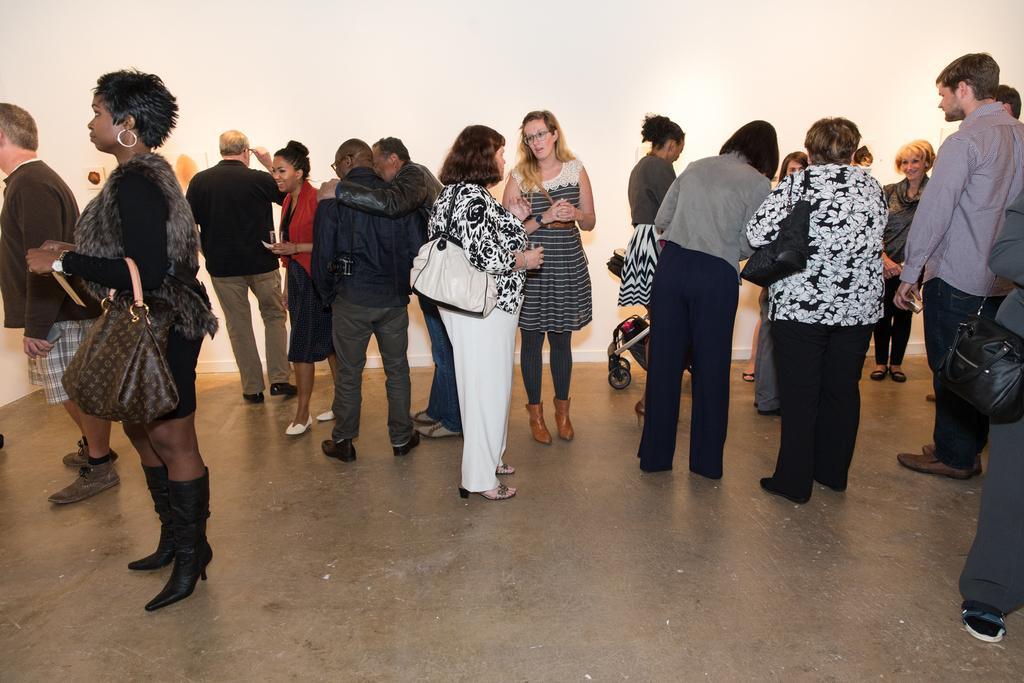How would you summarize this image in a sentence or two? In this picture we can see some persons standing on the floor. She is carrying her bag. On the background there is a wall. And this is the floor. 